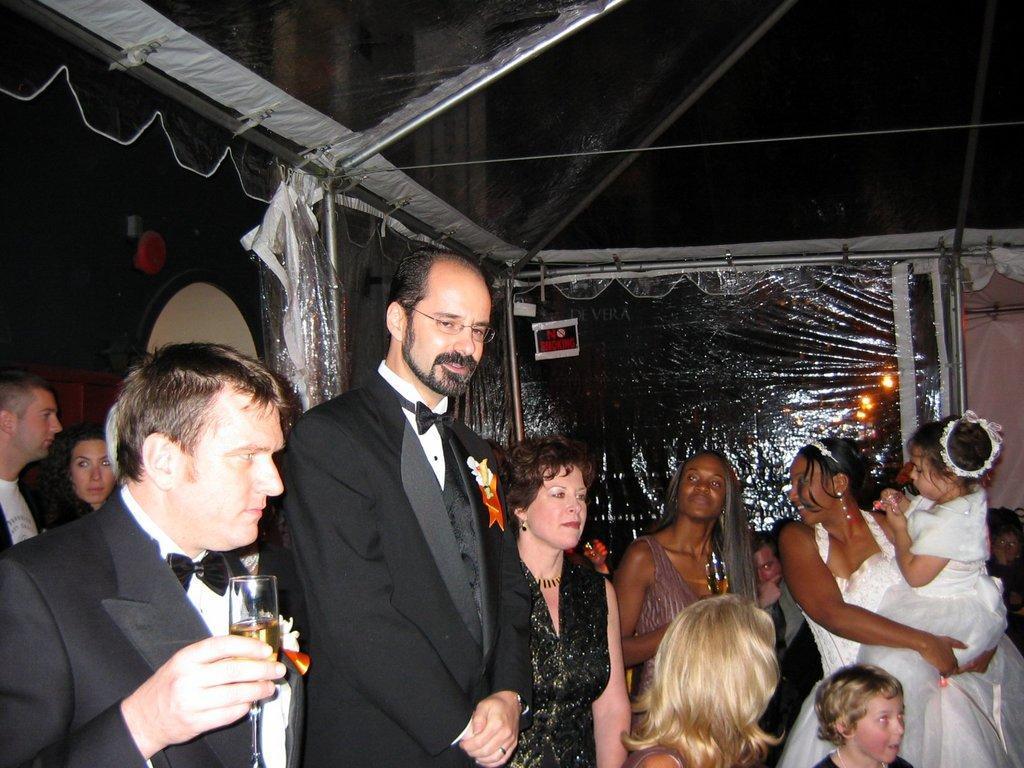Please provide a concise description of this image. In this image I can see few people around and they are wearing different color dress. In front the person is wearing black coat and black bow. Back I can see a black color tint and plastic cover. 